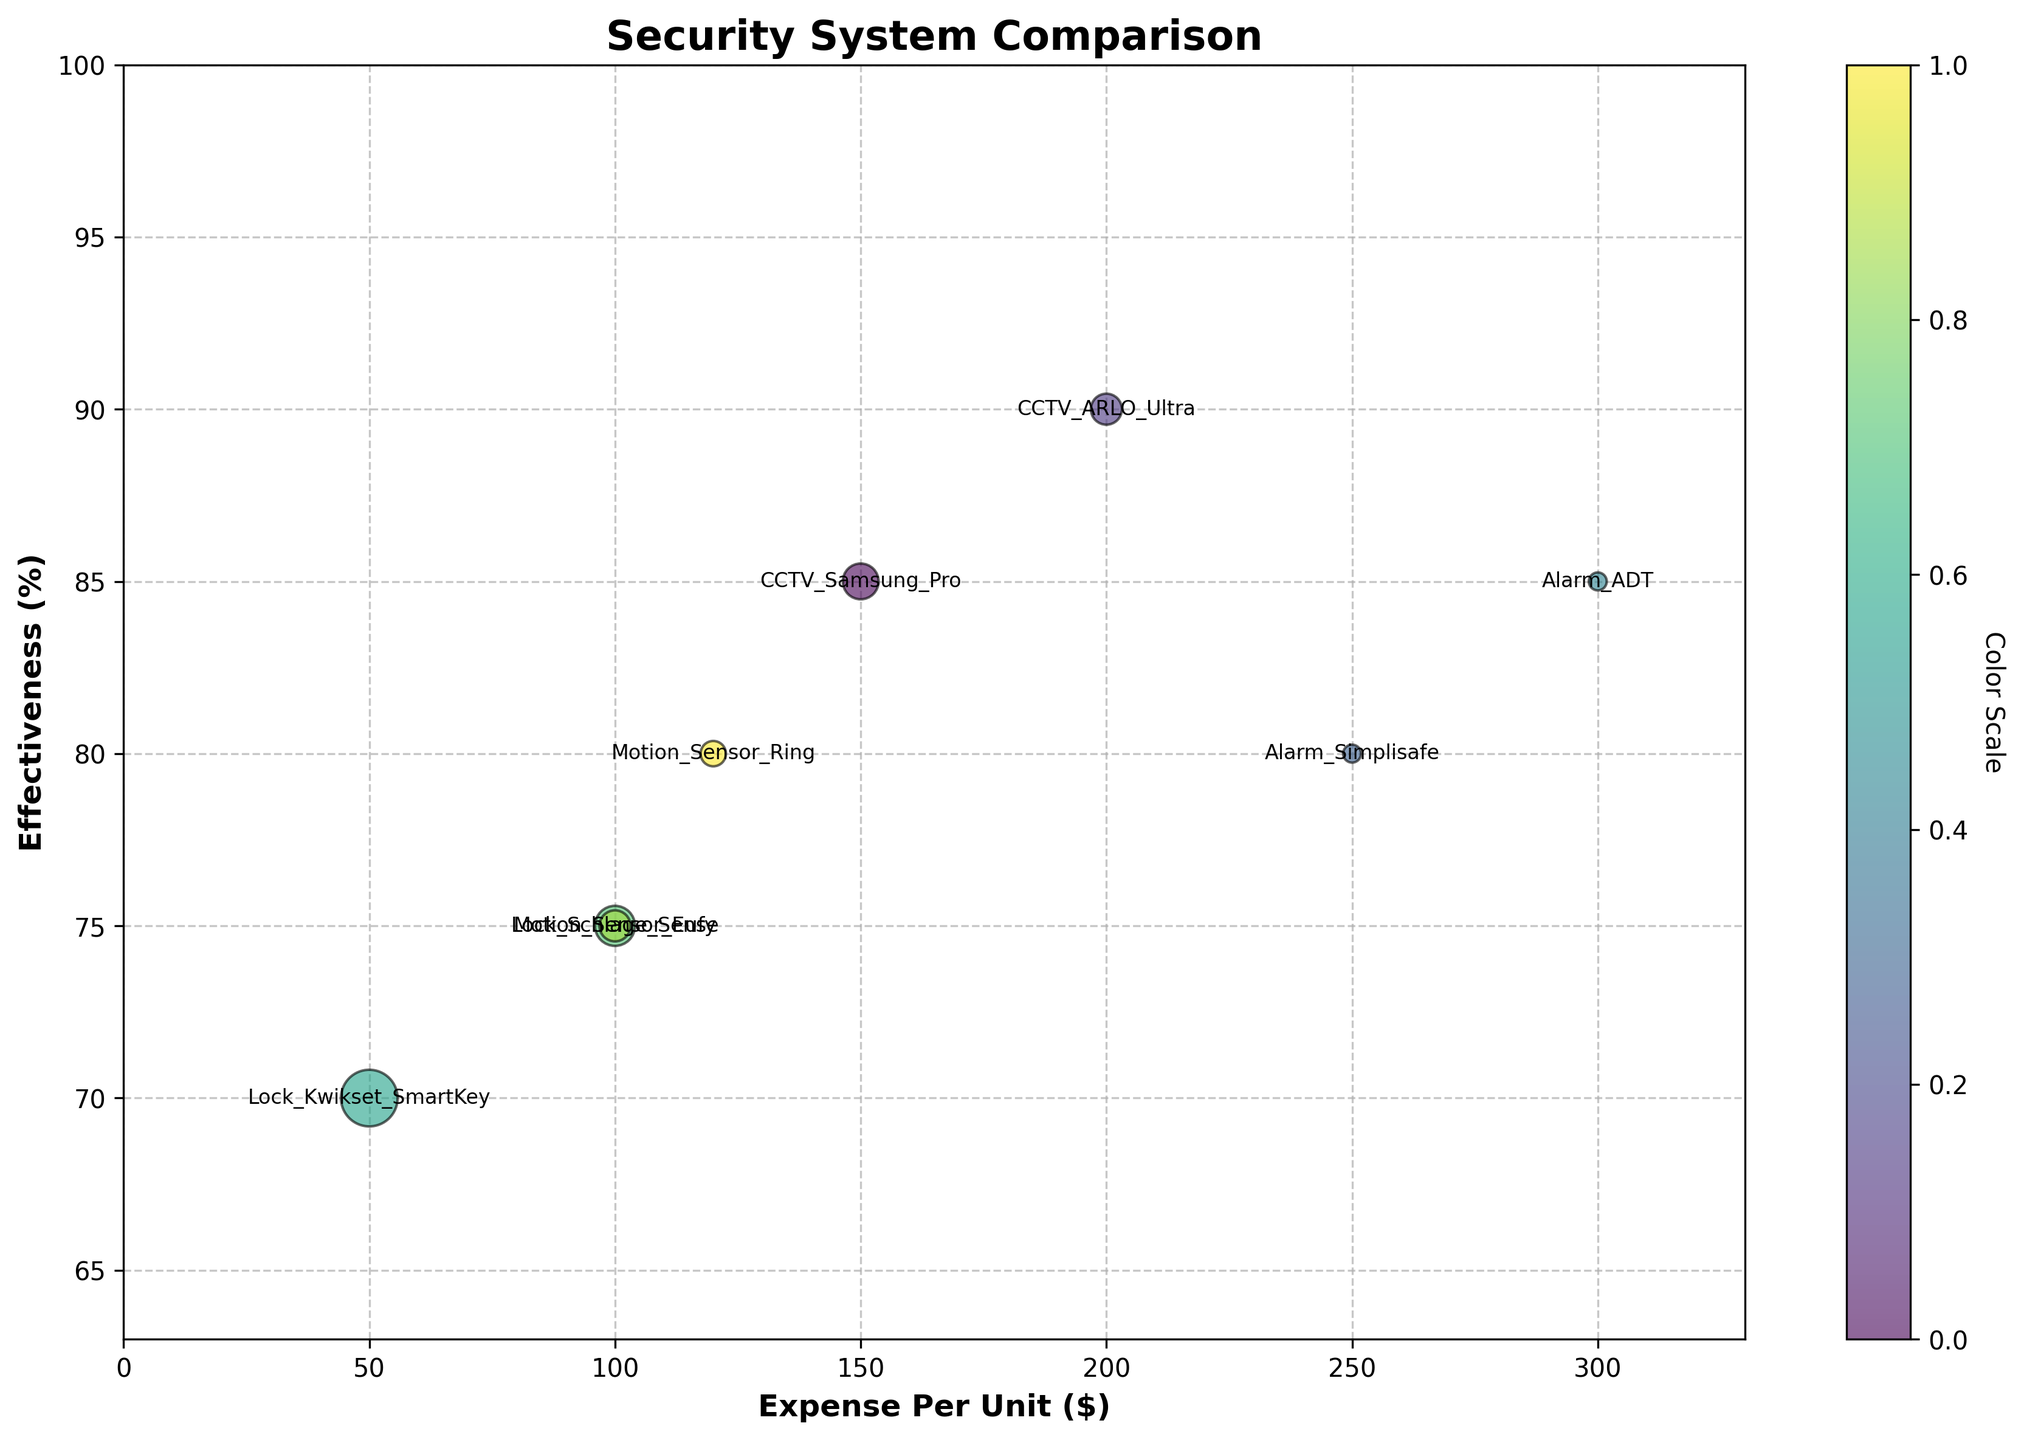What is the title of the figure? The title of the figure is usually displayed at the top and summarizes the main topic of the chart. In this case, the title reads "Security System Comparison".
Answer: Security System Comparison What does the x-axis represent? The x-axis typically represents one of the key variables being plotted. Here, it shows the "Expense Per Unit ($)" for various security systems.
Answer: Expense Per Unit ($) Which security system has the highest effectiveness? To find the security system with the highest effectiveness, locate the highest point on the y-axis, which is sorted from 0 to 100. The highest point on the y-axis reaches 90%, represented by "CCTV_ARLO_Ultra".
Answer: CCTV_ARLO_Ultra How many security system types are plotted? Each unique security system is represented by a bubble with a label. By counting the labels, we can identify there are 8 different security system types.
Answer: 8 Which security system has the largest bubble, and what does it represent? The size of the bubble is proportional to the "Total_Units". The largest bubble is "Lock_Kwikset_SmartKey", indicating it has the highest units (10).
Answer: Lock_Kwikset_SmartKey Which security system has the lowest expense per unit and what is its effectiveness? Locate the bubble furthest to the left on the x-axis. "Lock_Kwikset_SmartKey" has the lowest expense per unit at $50 and its effectiveness is 70%.
Answer: Lock_Kwikset_SmartKey at 70% How does the effectiveness of Alarm_Simplisafe compare to Alarm_ADT? Compare the y-axis values of the two labels. "Alarm_Simplisafe" is at 80%, and "Alarm_ADT" is at 85%, indicating Alarm_ADT is more effective.
Answer: Alarm_ADT is more effective Among the systems with an expense per unit below $150, which one has the highest effectiveness? Filter the systems by looking at the bubbles to the left of the $150 mark on the x-axis, then find the highest point on the y-axis among them. "CCTV_Samsung_Pro" has an expense per unit of $150 exactly and an effectiveness of 85%, which is the highest for values below $150.
Answer: CCTV_Samsung_Pro If I were to increase my budget for Motion_Sensor_Eufy, by how much would the expense per unit increase compared to Motion_Sensor_Ring? Find and compare the x-axis values for both systems. "Motion_Sensor_Eufy" costs $100, while "Motion_Sensor_Ring" costs $120. The increase would be $120 - $100 = $20.
Answer: $20 Which security system has the smallest bubble, and what are its expense per unit and effectiveness? The smallest bubble indicates the lowest number of units. "Alarm_Simplisafe" has only 1 unit, with an expense of $250 and effectiveness of 80%.
Answer: Alarm_Simplisafe, $250, 80% 